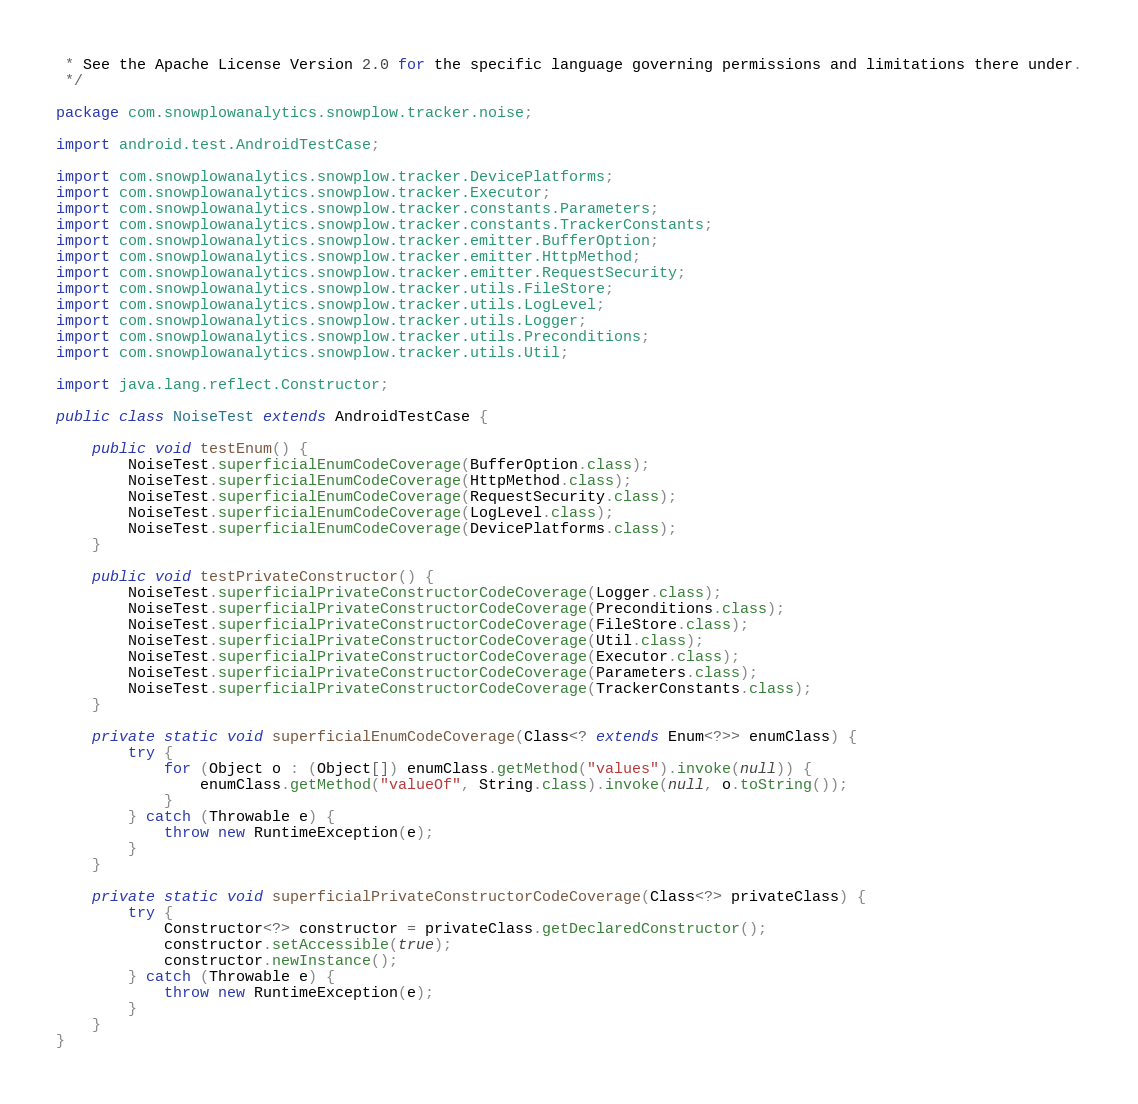Convert code to text. <code><loc_0><loc_0><loc_500><loc_500><_Java_> * See the Apache License Version 2.0 for the specific language governing permissions and limitations there under.
 */

package com.snowplowanalytics.snowplow.tracker.noise;

import android.test.AndroidTestCase;

import com.snowplowanalytics.snowplow.tracker.DevicePlatforms;
import com.snowplowanalytics.snowplow.tracker.Executor;
import com.snowplowanalytics.snowplow.tracker.constants.Parameters;
import com.snowplowanalytics.snowplow.tracker.constants.TrackerConstants;
import com.snowplowanalytics.snowplow.tracker.emitter.BufferOption;
import com.snowplowanalytics.snowplow.tracker.emitter.HttpMethod;
import com.snowplowanalytics.snowplow.tracker.emitter.RequestSecurity;
import com.snowplowanalytics.snowplow.tracker.utils.FileStore;
import com.snowplowanalytics.snowplow.tracker.utils.LogLevel;
import com.snowplowanalytics.snowplow.tracker.utils.Logger;
import com.snowplowanalytics.snowplow.tracker.utils.Preconditions;
import com.snowplowanalytics.snowplow.tracker.utils.Util;

import java.lang.reflect.Constructor;

public class NoiseTest extends AndroidTestCase {

    public void testEnum() {
        NoiseTest.superficialEnumCodeCoverage(BufferOption.class);
        NoiseTest.superficialEnumCodeCoverage(HttpMethod.class);
        NoiseTest.superficialEnumCodeCoverage(RequestSecurity.class);
        NoiseTest.superficialEnumCodeCoverage(LogLevel.class);
        NoiseTest.superficialEnumCodeCoverage(DevicePlatforms.class);
    }

    public void testPrivateConstructor() {
        NoiseTest.superficialPrivateConstructorCodeCoverage(Logger.class);
        NoiseTest.superficialPrivateConstructorCodeCoverage(Preconditions.class);
        NoiseTest.superficialPrivateConstructorCodeCoverage(FileStore.class);
        NoiseTest.superficialPrivateConstructorCodeCoverage(Util.class);
        NoiseTest.superficialPrivateConstructorCodeCoverage(Executor.class);
        NoiseTest.superficialPrivateConstructorCodeCoverage(Parameters.class);
        NoiseTest.superficialPrivateConstructorCodeCoverage(TrackerConstants.class);
    }

    private static void superficialEnumCodeCoverage(Class<? extends Enum<?>> enumClass) {
        try {
            for (Object o : (Object[]) enumClass.getMethod("values").invoke(null)) {
                enumClass.getMethod("valueOf", String.class).invoke(null, o.toString());
            }
        } catch (Throwable e) {
            throw new RuntimeException(e);
        }
    }

    private static void superficialPrivateConstructorCodeCoverage(Class<?> privateClass) {
        try {
            Constructor<?> constructor = privateClass.getDeclaredConstructor();
            constructor.setAccessible(true);
            constructor.newInstance();
        } catch (Throwable e) {
            throw new RuntimeException(e);
        }
    }
}
</code> 